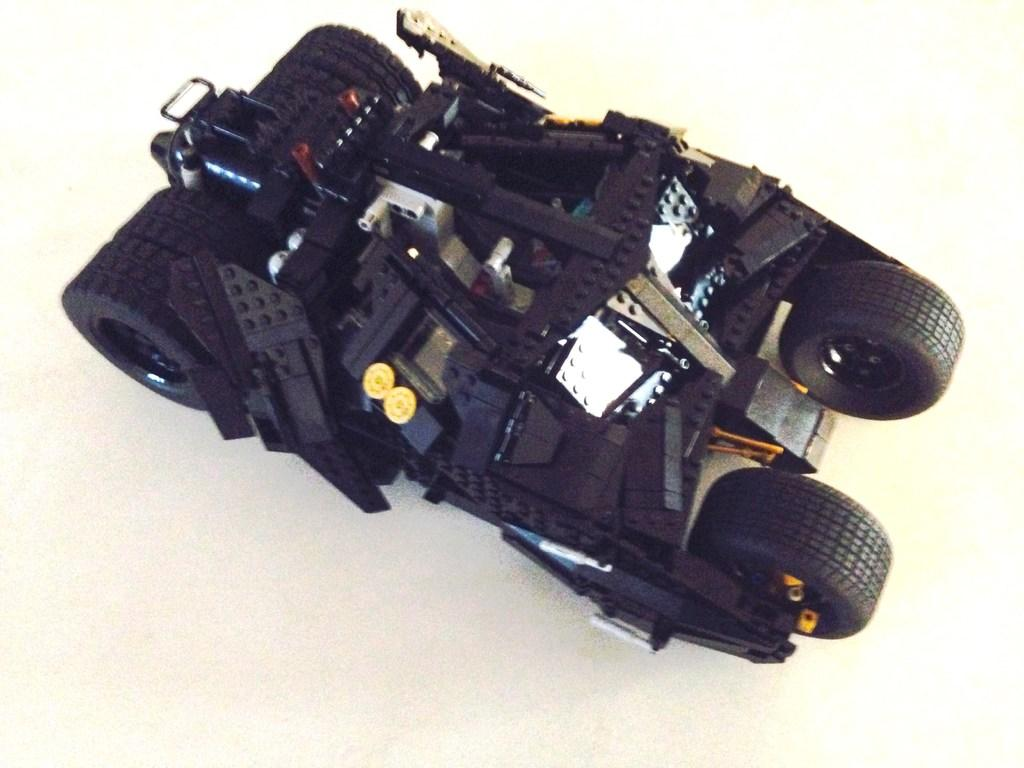What is the main object in the image? There is a toy car in the image. How many wheels does the toy car have? The toy car has four wheels. What type of pets are visible in the image? There are no pets visible in the image; it only features a toy car. Is there a gun present in the image? There is no gun present in the image; it only features a toy car. 